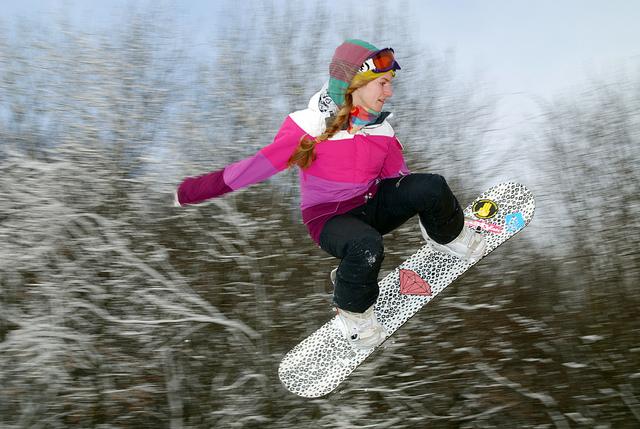What color is the gem decal on the snowboard?
Short answer required. Red. Is the girl skiing?
Concise answer only. No. Is she airborne?
Be succinct. Yes. 